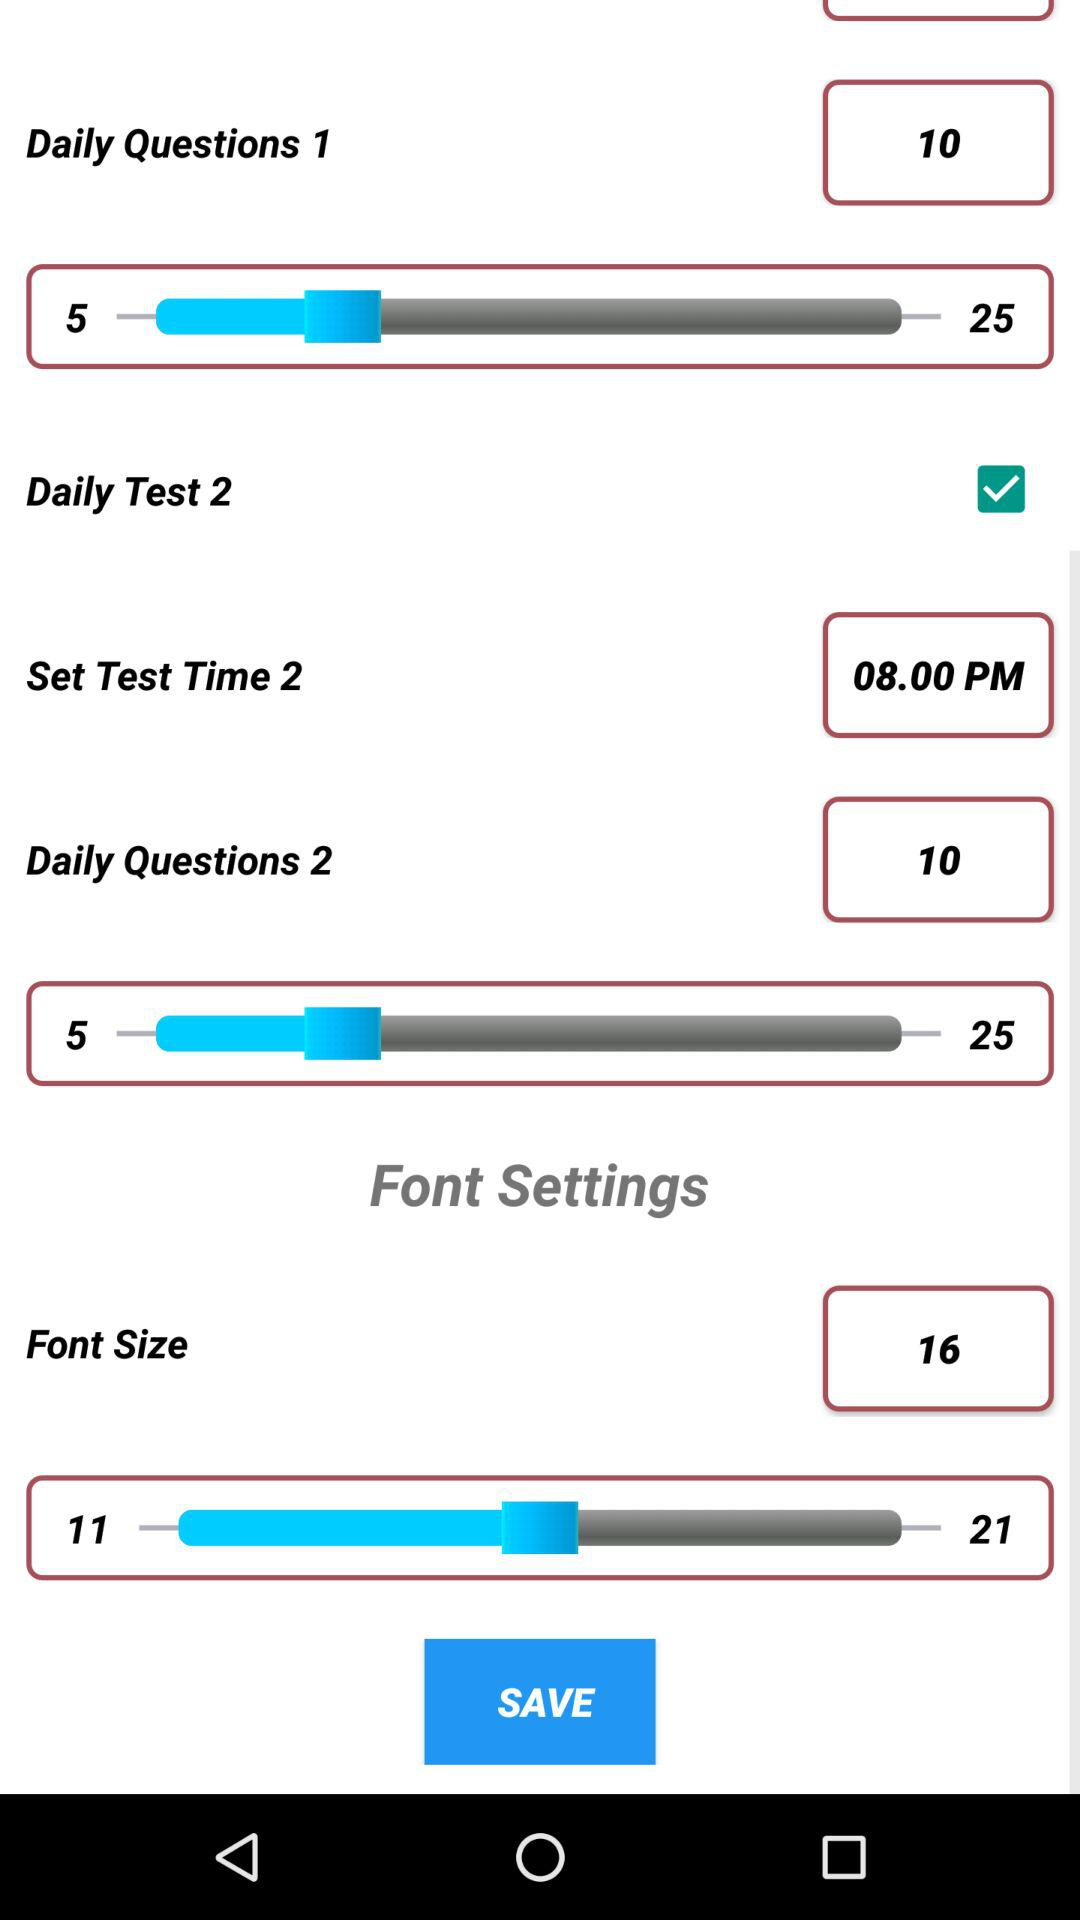What number of questions have been chosen for "Daily Question 2"? The number of questions is 10. 